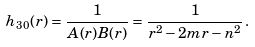<formula> <loc_0><loc_0><loc_500><loc_500>h _ { 3 0 } ( r ) = \frac { 1 } { A ( r ) B ( r ) } = \frac { 1 } { r ^ { 2 } - 2 m r - n ^ { 2 } } \, .</formula> 